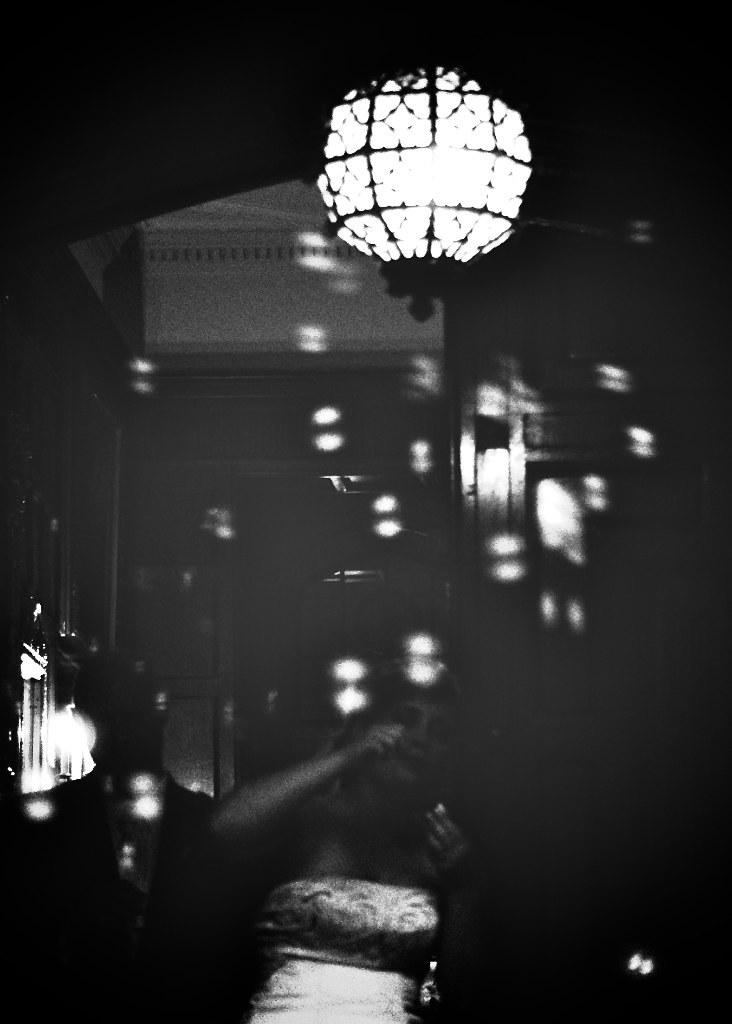What is the main subject in the image? There is a lady standing in the image. What can be seen at the top of the image? There is a light at the top of the image. What is visible in the background of the image? There is a wall and a door in the background of the image. What type of harmony is being played by the cat in the image? There is no cat present in the image, so there is no harmony being played. 